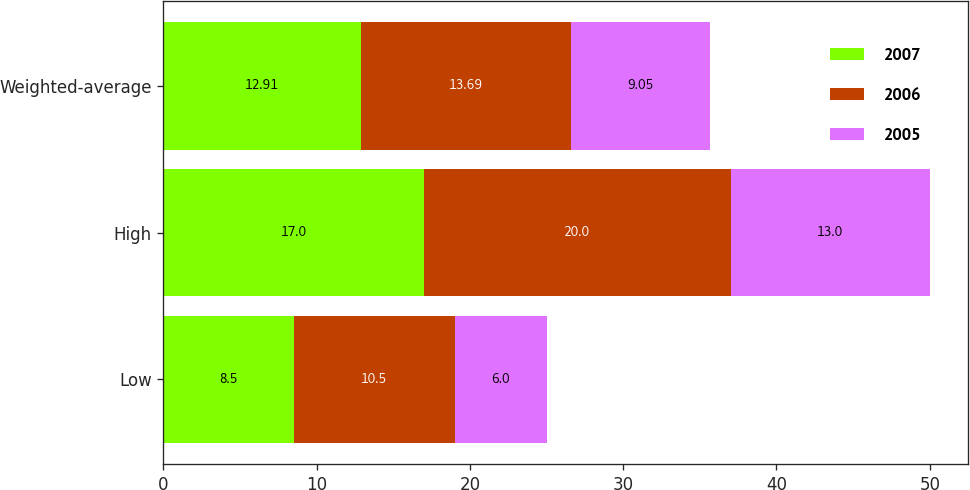<chart> <loc_0><loc_0><loc_500><loc_500><stacked_bar_chart><ecel><fcel>Low<fcel>High<fcel>Weighted-average<nl><fcel>2007<fcel>8.5<fcel>17<fcel>12.91<nl><fcel>2006<fcel>10.5<fcel>20<fcel>13.69<nl><fcel>2005<fcel>6<fcel>13<fcel>9.05<nl></chart> 